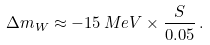<formula> <loc_0><loc_0><loc_500><loc_500>\Delta m _ { W } \approx - 1 5 \, M e V \times \frac { S } { 0 . 0 5 } \, .</formula> 